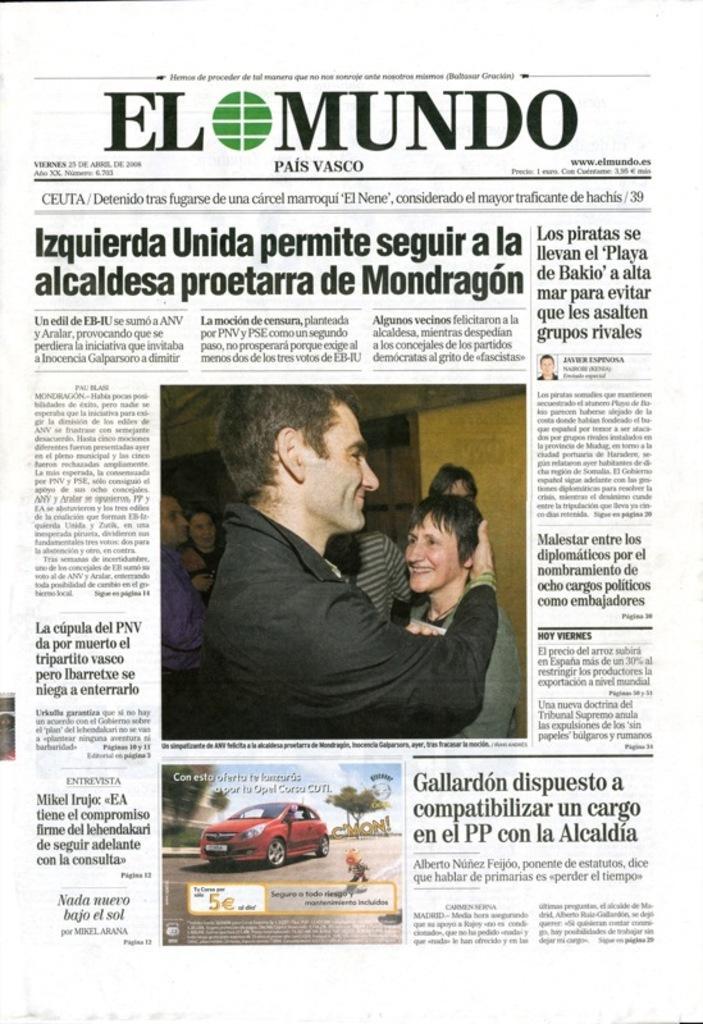Could you give a brief overview of what you see in this image? This image consists of a paper with a few images of men, women and a car and there is a text on the paper. 